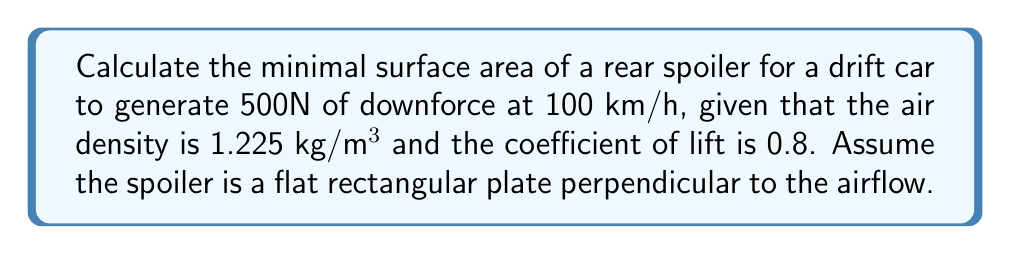Teach me how to tackle this problem. To solve this problem, we'll use the lift equation and minimize the surface area while maintaining the required downforce. Let's break it down step-by-step:

1) The lift equation is:
   $$F = \frac{1}{2} \rho v^2 C_L A$$
   where:
   $F$ = lift force (negative for downforce)
   $\rho$ = air density
   $v$ = velocity
   $C_L$ = coefficient of lift
   $A$ = surface area

2) We're given:
   $F = -500 \text{ N}$ (negative because it's downforce)
   $\rho = 1.225 \text{ kg/m}^3$
   $v = 100 \text{ km/h} = 27.78 \text{ m/s}$
   $C_L = 0.8$

3) Substitute these values into the lift equation:
   $$-500 = \frac{1}{2} (1.225)(27.78^2)(0.8)A$$

4) Solve for $A$:
   $$A = \frac{-500}{\frac{1}{2}(1.225)(27.78^2)(0.8)} = 0.6718 \text{ m}^2$$

5) To minimize the surface area, we need to ensure that the spoiler is exactly this size, as any larger area would produce unnecessary drag.

[asy]
size(200,100);
draw((0,0)--(100,0)--(100,50)--(0,50)--cycle);
label("0.82 m", (50,0), S);
label("0.82 m", (0,25), W);
draw((110,0)--(130,0),Arrow);
label("Airflow", (120,10), E);
[/asy]

6) The minimal dimensions of the rectangular spoiler would be:
   $$\sqrt{0.6718} \text{ m } \times \sqrt{0.6718} \text{ m}$$
   Which is approximately 0.82 m × 0.82 m.
Answer: 0.6718 m² 